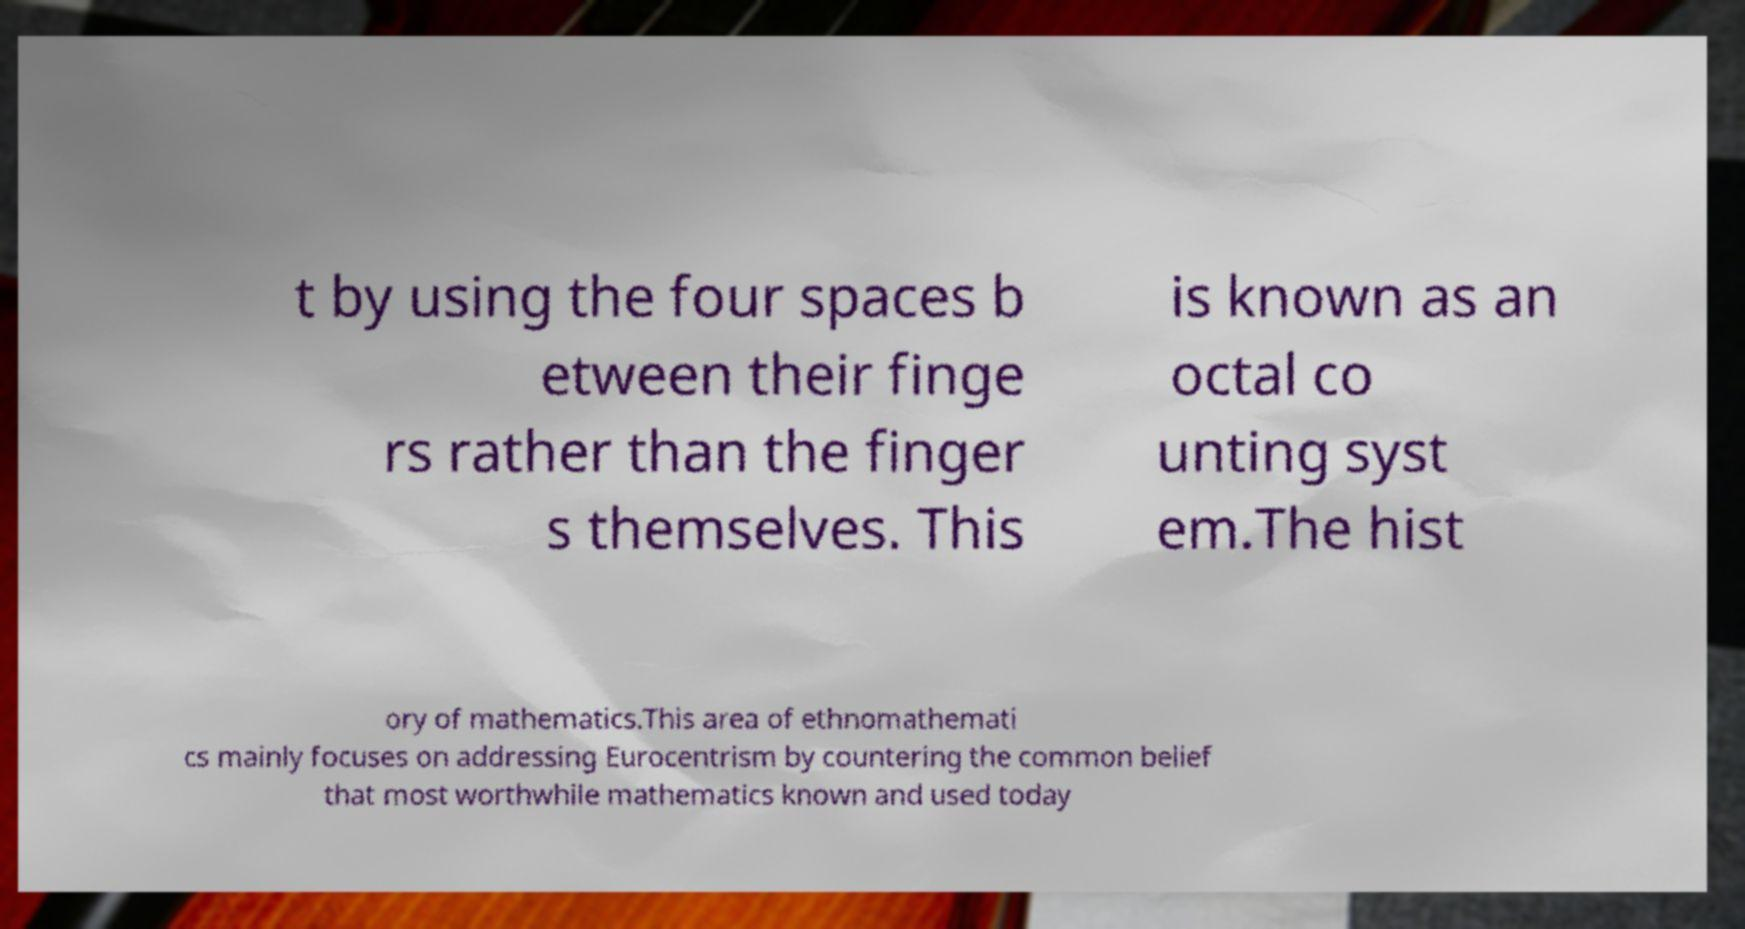Please read and relay the text visible in this image. What does it say? t by using the four spaces b etween their finge rs rather than the finger s themselves. This is known as an octal co unting syst em.The hist ory of mathematics.This area of ethnomathemati cs mainly focuses on addressing Eurocentrism by countering the common belief that most worthwhile mathematics known and used today 